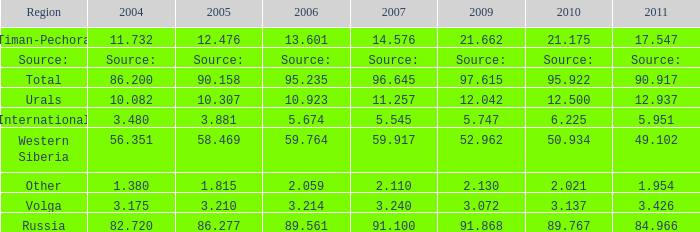What is the 2004 Lukoil oil prodroduction when in 2011 oil production 90.917 million tonnes? 86.2. 